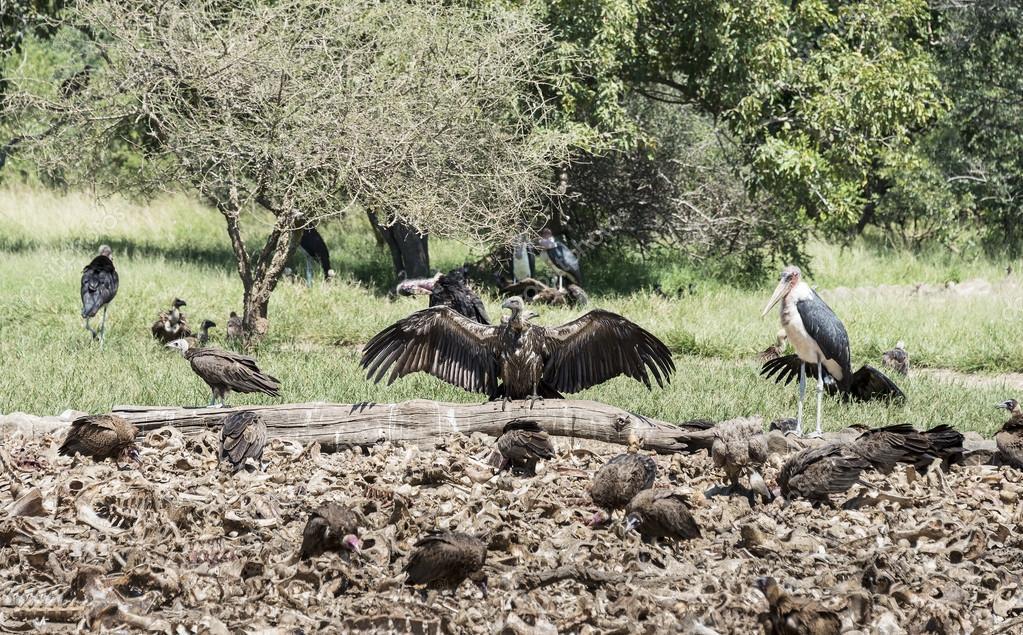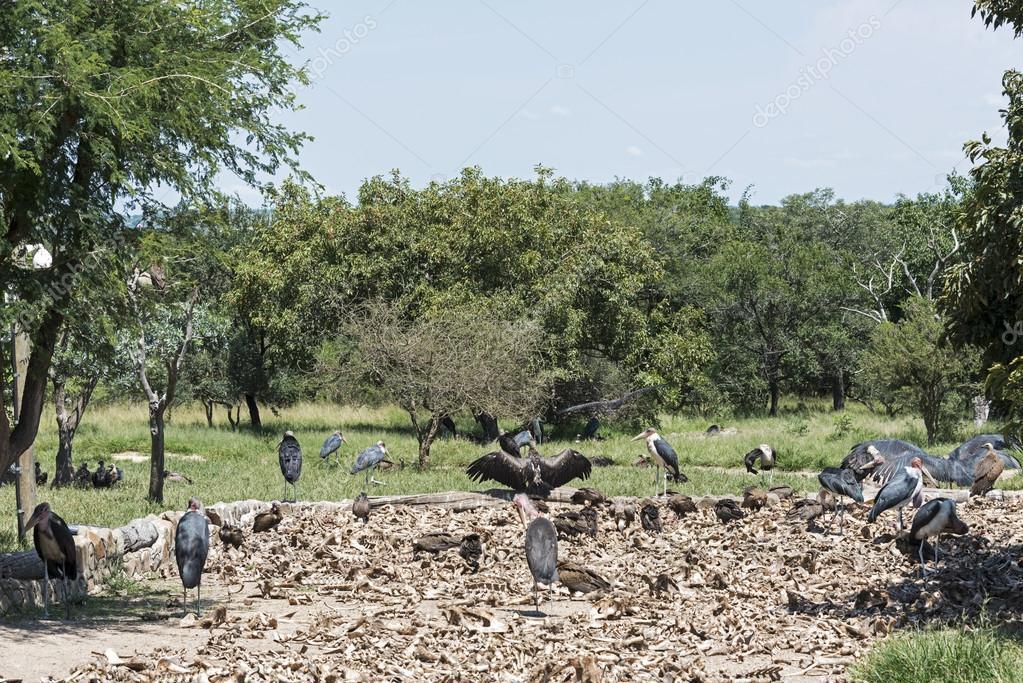The first image is the image on the left, the second image is the image on the right. Considering the images on both sides, is "None of the birds have outstretched wings in the image on the left." valid? Answer yes or no. No. 